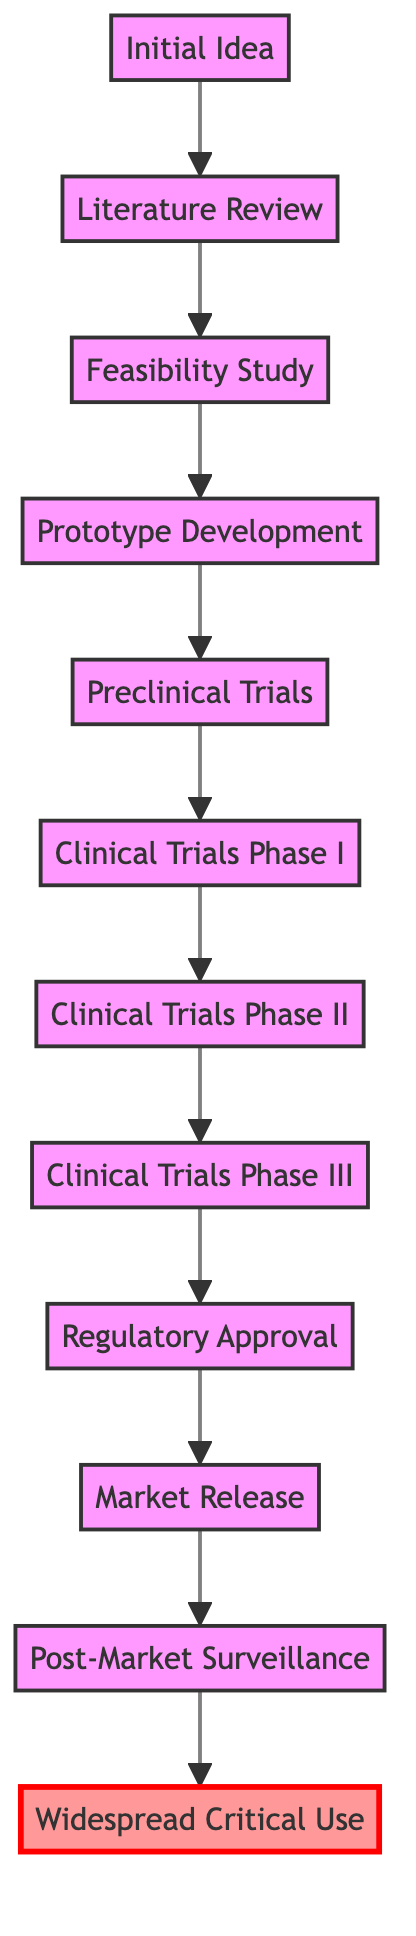What is the first stage in the flow chart? The flow chart starts with "Initial Idea" as the first stage, which leads to the next stage of "Literature Review."
Answer: Initial Idea How many stages are there in total? Counting all the stages from "Initial Idea" to "Widespread Critical Use," there are a total of 12 stages in the flow chart.
Answer: 12 What follows after "Clinical Trials Phase I"? The diagram shows that after "Clinical Trials Phase I," the next stage is "Clinical Trials Phase II."
Answer: Clinical Trials Phase II What is the final stage in the flow chart? The flow chart ends with "Widespread Critical Use," indicating the achievement of extensive adoption of the medical technology.
Answer: Widespread Critical Use Which stage focuses on evaluating safety in humans? "Clinical Trials Phase I" is the stage dedicated to assessing safety in a small group of human volunteers.
Answer: Clinical Trials Phase I What is the purpose of the "Regulatory Approval" stage? The "Regulatory Approval" stage is for submitting trial results to regulatory bodies like the FDA for approval to use the new medical technology.
Answer: Submission of trial results How does "Preclinical Trials" relate to "Prototype Development"? "Preclinical Trials" follows "Prototype Development," indicating it's the testing phase after creating an initial prototype, focusing on safety and efficacy.
Answer: Preclinical Trials follows Prototype Development Which stage comes immediately before "Market Release"? The stage that comes immediately before "Market Release" is "Regulatory Approval," necessary to launch the technology commercially.
Answer: Regulatory Approval What distinguishes "Widespread Critical Use" from "Market Release"? "Widespread Critical Use" indicates that the technology has achieved significant adoption and is a critical tool, while "Market Release" is simply when it is launched for use.
Answer: Widespread adoption and critical tool 